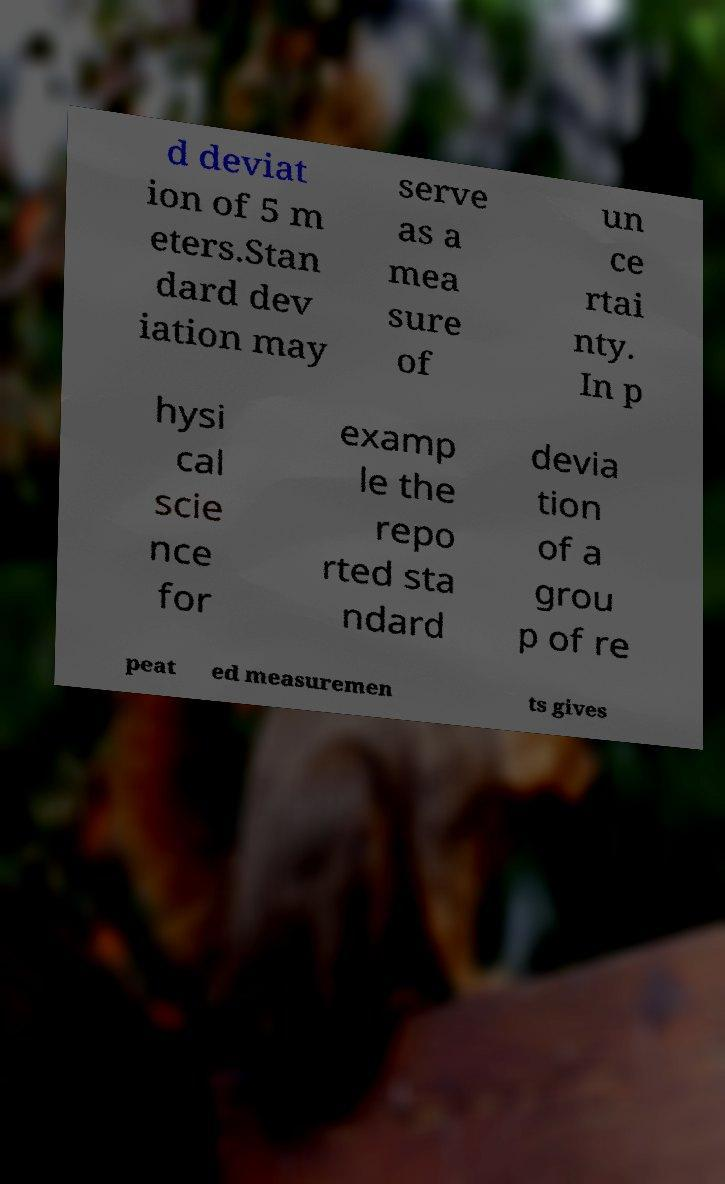Can you read and provide the text displayed in the image?This photo seems to have some interesting text. Can you extract and type it out for me? d deviat ion of 5 m eters.Stan dard dev iation may serve as a mea sure of un ce rtai nty. In p hysi cal scie nce for examp le the repo rted sta ndard devia tion of a grou p of re peat ed measuremen ts gives 